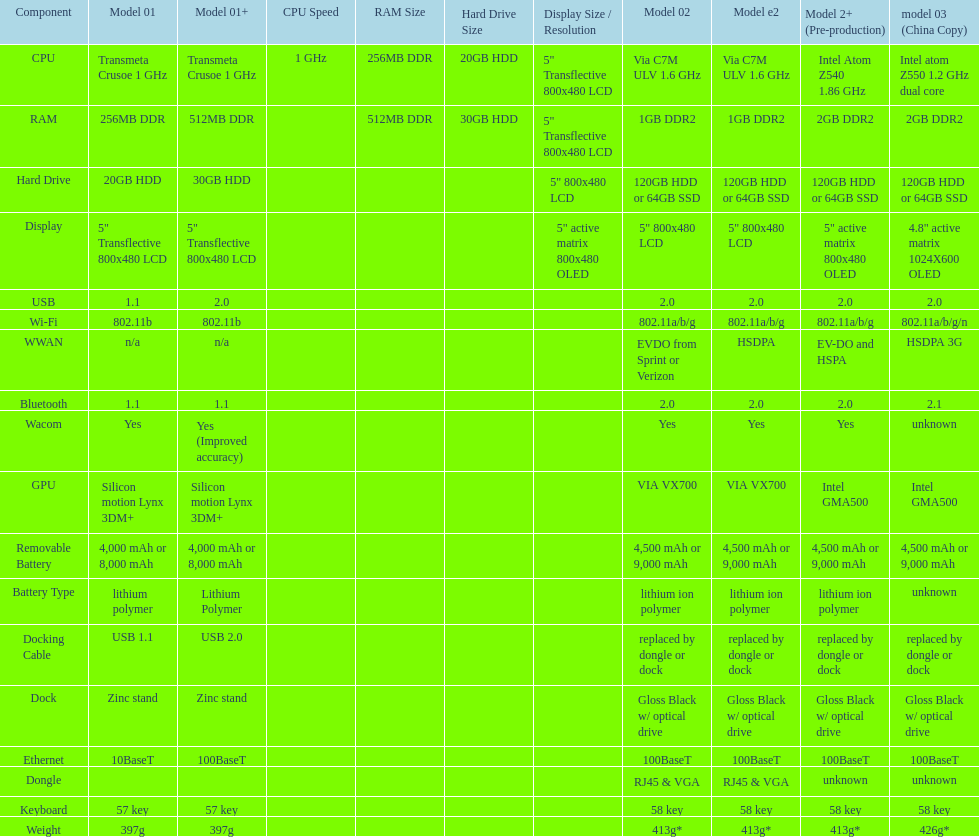Which model weighs the most, according to the table? Model 03 (china copy). 